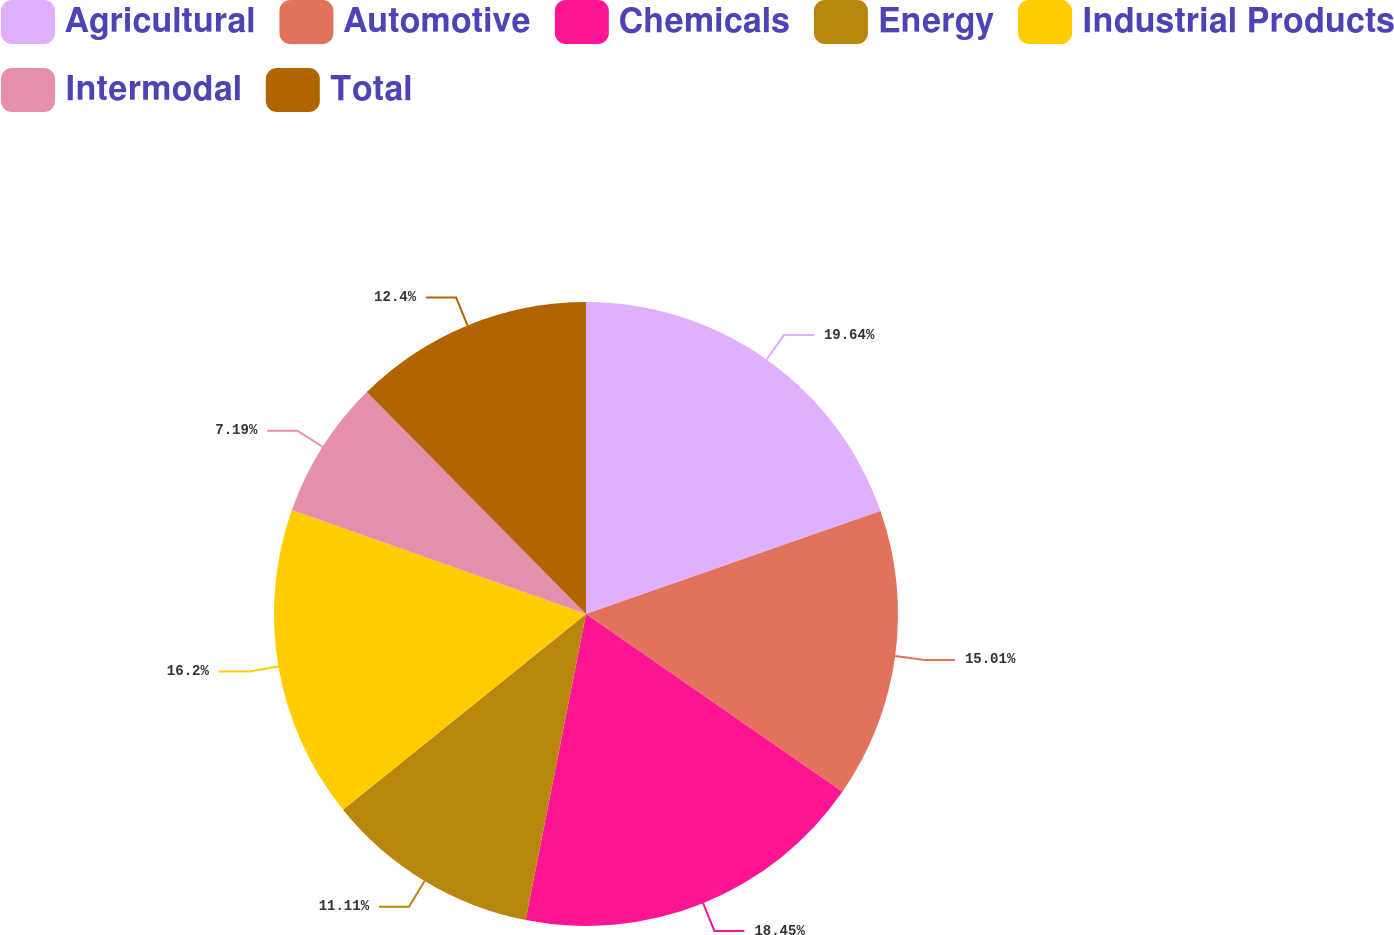Convert chart. <chart><loc_0><loc_0><loc_500><loc_500><pie_chart><fcel>Agricultural<fcel>Automotive<fcel>Chemicals<fcel>Energy<fcel>Industrial Products<fcel>Intermodal<fcel>Total<nl><fcel>19.64%<fcel>15.01%<fcel>18.45%<fcel>11.11%<fcel>16.2%<fcel>7.19%<fcel>12.4%<nl></chart> 